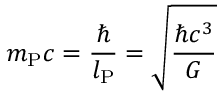<formula> <loc_0><loc_0><loc_500><loc_500>m _ { P } c = { \frac { } { l _ { P } } } = { \sqrt { \frac { \hbar { c } ^ { 3 } } { G } } }</formula> 